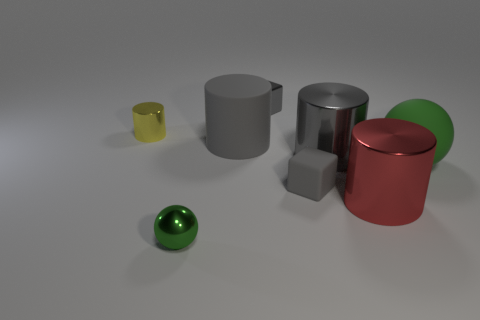There is a tiny rubber block; is its color the same as the ball on the right side of the green shiny sphere?
Make the answer very short. No. What is the size of the cube in front of the cylinder left of the green sphere left of the tiny gray metal thing?
Keep it short and to the point. Small. What number of balls have the same color as the shiny block?
Your answer should be very brief. 0. How many things are either small green balls or metal things that are in front of the small yellow thing?
Keep it short and to the point. 3. The matte ball is what color?
Your answer should be very brief. Green. There is a big matte object that is left of the large red thing; what is its color?
Offer a terse response. Gray. How many large red shiny things are on the right side of the cylinder left of the tiny green thing?
Offer a terse response. 1. Is the size of the green shiny thing the same as the cube that is behind the tiny cylinder?
Make the answer very short. Yes. Are there any metal things of the same size as the red cylinder?
Your answer should be compact. Yes. What number of objects are either small green metallic objects or large matte things?
Make the answer very short. 3. 